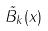<formula> <loc_0><loc_0><loc_500><loc_500>\tilde { B } _ { k } ( x )</formula> 